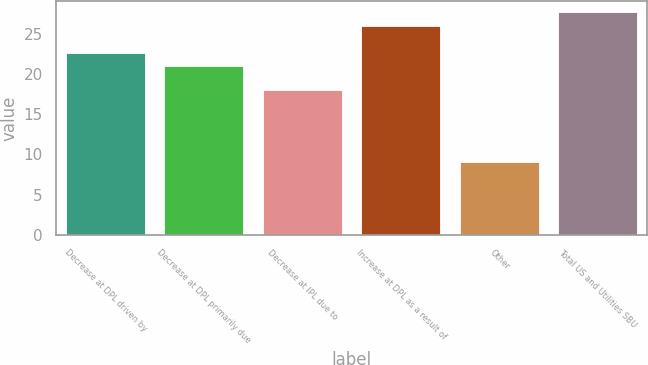Convert chart to OTSL. <chart><loc_0><loc_0><loc_500><loc_500><bar_chart><fcel>Decrease at DPL driven by<fcel>Decrease at DPL primarily due<fcel>Decrease at IPL due to<fcel>Increase at DPL as a result of<fcel>Other<fcel>Total US and Utilities SBU<nl><fcel>22.7<fcel>21<fcel>18<fcel>26<fcel>9<fcel>27.7<nl></chart> 